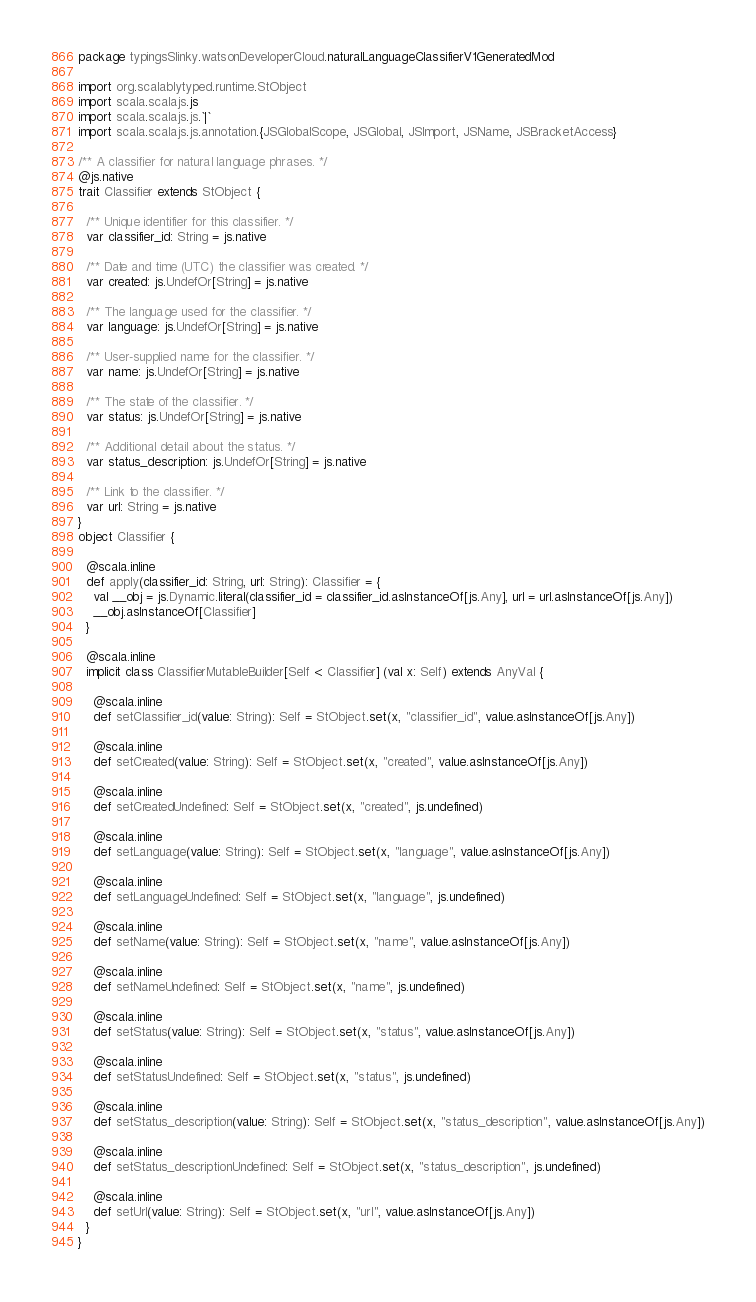<code> <loc_0><loc_0><loc_500><loc_500><_Scala_>package typingsSlinky.watsonDeveloperCloud.naturalLanguageClassifierV1GeneratedMod

import org.scalablytyped.runtime.StObject
import scala.scalajs.js
import scala.scalajs.js.`|`
import scala.scalajs.js.annotation.{JSGlobalScope, JSGlobal, JSImport, JSName, JSBracketAccess}

/** A classifier for natural language phrases. */
@js.native
trait Classifier extends StObject {
  
  /** Unique identifier for this classifier. */
  var classifier_id: String = js.native
  
  /** Date and time (UTC) the classifier was created. */
  var created: js.UndefOr[String] = js.native
  
  /** The language used for the classifier. */
  var language: js.UndefOr[String] = js.native
  
  /** User-supplied name for the classifier. */
  var name: js.UndefOr[String] = js.native
  
  /** The state of the classifier. */
  var status: js.UndefOr[String] = js.native
  
  /** Additional detail about the status. */
  var status_description: js.UndefOr[String] = js.native
  
  /** Link to the classifier. */
  var url: String = js.native
}
object Classifier {
  
  @scala.inline
  def apply(classifier_id: String, url: String): Classifier = {
    val __obj = js.Dynamic.literal(classifier_id = classifier_id.asInstanceOf[js.Any], url = url.asInstanceOf[js.Any])
    __obj.asInstanceOf[Classifier]
  }
  
  @scala.inline
  implicit class ClassifierMutableBuilder[Self <: Classifier] (val x: Self) extends AnyVal {
    
    @scala.inline
    def setClassifier_id(value: String): Self = StObject.set(x, "classifier_id", value.asInstanceOf[js.Any])
    
    @scala.inline
    def setCreated(value: String): Self = StObject.set(x, "created", value.asInstanceOf[js.Any])
    
    @scala.inline
    def setCreatedUndefined: Self = StObject.set(x, "created", js.undefined)
    
    @scala.inline
    def setLanguage(value: String): Self = StObject.set(x, "language", value.asInstanceOf[js.Any])
    
    @scala.inline
    def setLanguageUndefined: Self = StObject.set(x, "language", js.undefined)
    
    @scala.inline
    def setName(value: String): Self = StObject.set(x, "name", value.asInstanceOf[js.Any])
    
    @scala.inline
    def setNameUndefined: Self = StObject.set(x, "name", js.undefined)
    
    @scala.inline
    def setStatus(value: String): Self = StObject.set(x, "status", value.asInstanceOf[js.Any])
    
    @scala.inline
    def setStatusUndefined: Self = StObject.set(x, "status", js.undefined)
    
    @scala.inline
    def setStatus_description(value: String): Self = StObject.set(x, "status_description", value.asInstanceOf[js.Any])
    
    @scala.inline
    def setStatus_descriptionUndefined: Self = StObject.set(x, "status_description", js.undefined)
    
    @scala.inline
    def setUrl(value: String): Self = StObject.set(x, "url", value.asInstanceOf[js.Any])
  }
}
</code> 